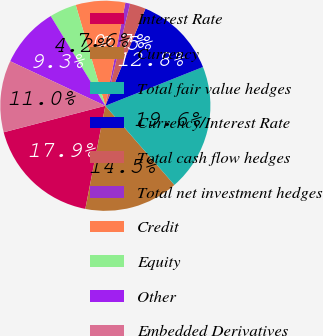Convert chart. <chart><loc_0><loc_0><loc_500><loc_500><pie_chart><fcel>Interest Rate<fcel>Currency<fcel>Total fair value hedges<fcel>Currency/Interest Rate<fcel>Total cash flow hedges<fcel>Total net investment hedges<fcel>Credit<fcel>Equity<fcel>Other<fcel>Embedded Derivatives<nl><fcel>17.89%<fcel>14.47%<fcel>19.6%<fcel>12.75%<fcel>2.45%<fcel>0.73%<fcel>7.6%<fcel>4.16%<fcel>9.32%<fcel>11.03%<nl></chart> 